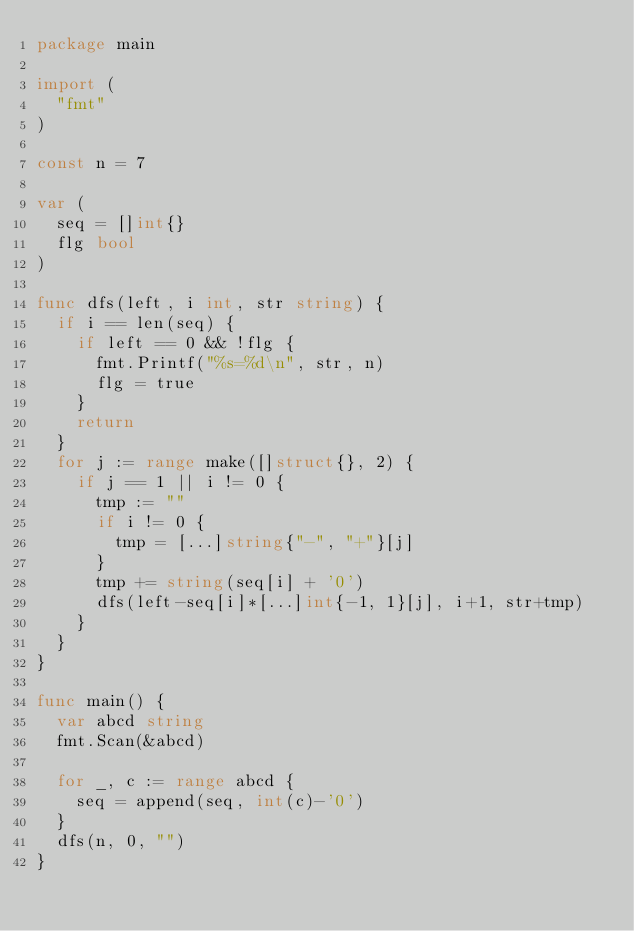<code> <loc_0><loc_0><loc_500><loc_500><_Go_>package main

import (
	"fmt"
)

const n = 7

var (
	seq = []int{}
	flg bool
)

func dfs(left, i int, str string) {
	if i == len(seq) {
		if left == 0 && !flg {
			fmt.Printf("%s=%d\n", str, n)
			flg = true
		}
		return
	}
	for j := range make([]struct{}, 2) {
		if j == 1 || i != 0 {
			tmp := ""
			if i != 0 {
				tmp = [...]string{"-", "+"}[j]
			}
			tmp += string(seq[i] + '0')
			dfs(left-seq[i]*[...]int{-1, 1}[j], i+1, str+tmp)
		}
	}
}

func main() {
	var abcd string
	fmt.Scan(&abcd)

	for _, c := range abcd {
		seq = append(seq, int(c)-'0')
	}
	dfs(n, 0, "")
}
</code> 